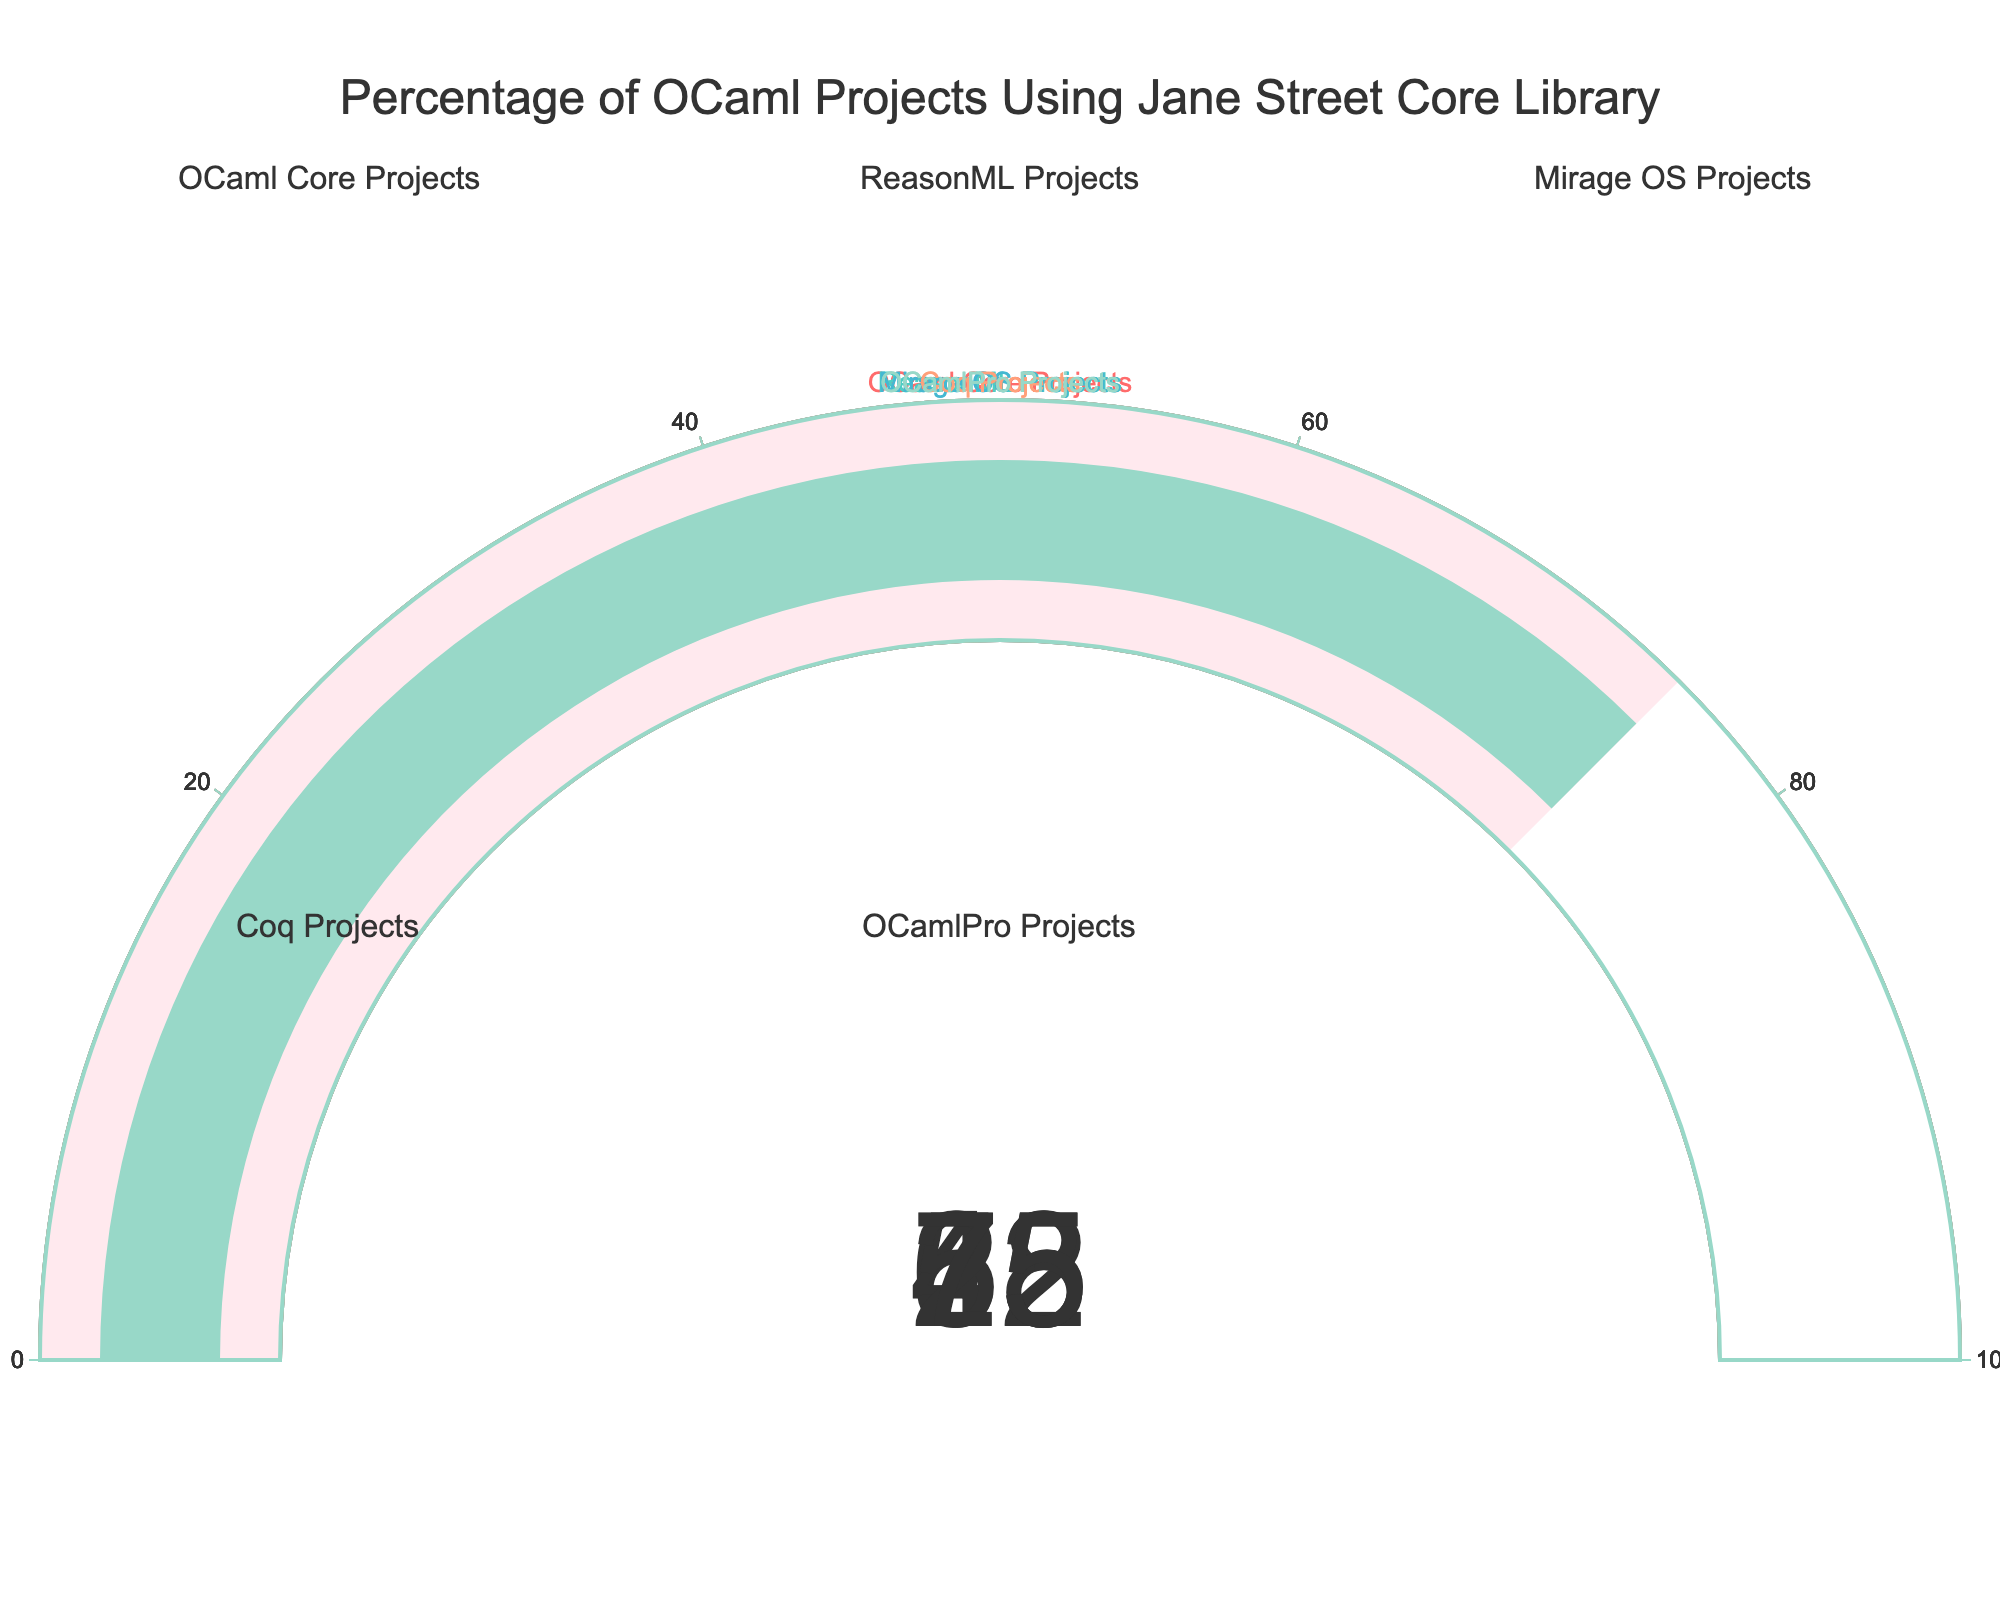What is the highest percentage displayed on the gauge charts? First, look at all the gauge charts and identify the percentage values depicted on each. The highest percentage is 75% in the OCamlPro Projects gauge.
Answer: 75% Which project shows the lowest percentage of OCaml projects using the Jane Street Core library? Examine each gauge chart to find which one displays the lowest percentage. The Coq Projects gauge shows the lowest value at 23%.
Answer: Coq Projects How many projects have a percentage greater than 50%? To find this, count how many gauges have a percentage above 50%. The OCaml Core Projects (68%), Mirage OS Projects (55%), and OCamlPro Projects (75%) all meet this criterion.
Answer: 3 Calculate the average percentage of the OCaml projects using the Jane Street Core library across all projects. Sum the percentage values of all the projects (68 + 42 + 55 + 23 + 75 = 263) and divide by the number of projects (5). The average is 263/5 = 52.6%.
Answer: 52.6% Compare the percentages of the ReasonML Projects and Mirage OS Projects. Which one is higher? Look at the gauge charts for both ReasonML Projects and Mirage OS Projects. The ReasonML Projects have 42%, and the Mirage OS Projects have 55%. The latter is higher.
Answer: Mirage OS Projects What is the range of the percentages shown in the gauge charts? To find the range, subtract the lowest value (23% from Coq Projects) from the highest value (75% from OCamlPro Projects). The range is 75% - 23% = 52%.
Answer: 52% What is the difference in percentage between OCaml Core Projects and OCamlPro Projects? Find the percentage for both gauges (OCaml Core Projects is 68%, and OCamlPro Projects is 75%) and calculate the difference: 75% - 68% = 7%.
Answer: 7% Which color is used for the OCaml Core Projects gauge in the figure? Each gauge is associated with a specific color. The OCaml Core Projects gauge uses a red hue (#FF6B6B).
Answer: Red 